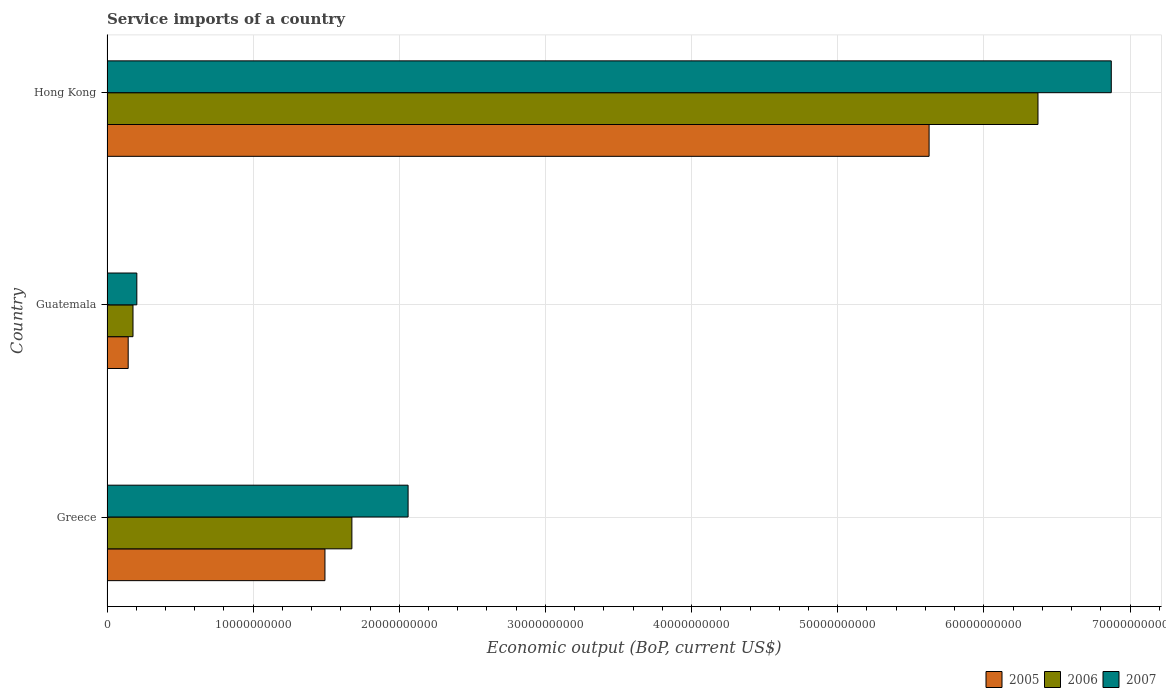Are the number of bars per tick equal to the number of legend labels?
Provide a succinct answer. Yes. Are the number of bars on each tick of the Y-axis equal?
Ensure brevity in your answer.  Yes. What is the label of the 2nd group of bars from the top?
Ensure brevity in your answer.  Guatemala. In how many cases, is the number of bars for a given country not equal to the number of legend labels?
Offer a very short reply. 0. What is the service imports in 2005 in Hong Kong?
Ensure brevity in your answer.  5.63e+1. Across all countries, what is the maximum service imports in 2005?
Ensure brevity in your answer.  5.63e+1. Across all countries, what is the minimum service imports in 2005?
Make the answer very short. 1.45e+09. In which country was the service imports in 2006 maximum?
Give a very brief answer. Hong Kong. In which country was the service imports in 2006 minimum?
Your response must be concise. Guatemala. What is the total service imports in 2005 in the graph?
Your answer should be compact. 7.26e+1. What is the difference between the service imports in 2007 in Guatemala and that in Hong Kong?
Offer a very short reply. -6.67e+1. What is the difference between the service imports in 2007 in Greece and the service imports in 2005 in Hong Kong?
Your answer should be very brief. -3.57e+1. What is the average service imports in 2005 per country?
Keep it short and to the point. 2.42e+1. What is the difference between the service imports in 2006 and service imports in 2005 in Guatemala?
Give a very brief answer. 3.29e+08. What is the ratio of the service imports in 2006 in Greece to that in Guatemala?
Make the answer very short. 9.42. Is the service imports in 2006 in Guatemala less than that in Hong Kong?
Provide a succinct answer. Yes. What is the difference between the highest and the second highest service imports in 2007?
Offer a terse response. 4.81e+1. What is the difference between the highest and the lowest service imports in 2006?
Your answer should be very brief. 6.19e+1. Is the sum of the service imports in 2006 in Greece and Hong Kong greater than the maximum service imports in 2007 across all countries?
Provide a succinct answer. Yes. Are all the bars in the graph horizontal?
Your response must be concise. Yes. How many countries are there in the graph?
Your answer should be compact. 3. Does the graph contain grids?
Your answer should be very brief. Yes. Where does the legend appear in the graph?
Your answer should be compact. Bottom right. How many legend labels are there?
Offer a very short reply. 3. What is the title of the graph?
Ensure brevity in your answer.  Service imports of a country. Does "1977" appear as one of the legend labels in the graph?
Your answer should be very brief. No. What is the label or title of the X-axis?
Make the answer very short. Economic output (BoP, current US$). What is the label or title of the Y-axis?
Make the answer very short. Country. What is the Economic output (BoP, current US$) of 2005 in Greece?
Your response must be concise. 1.49e+1. What is the Economic output (BoP, current US$) in 2006 in Greece?
Offer a very short reply. 1.68e+1. What is the Economic output (BoP, current US$) in 2007 in Greece?
Your answer should be very brief. 2.06e+1. What is the Economic output (BoP, current US$) in 2005 in Guatemala?
Provide a succinct answer. 1.45e+09. What is the Economic output (BoP, current US$) in 2006 in Guatemala?
Provide a succinct answer. 1.78e+09. What is the Economic output (BoP, current US$) in 2007 in Guatemala?
Provide a short and direct response. 2.04e+09. What is the Economic output (BoP, current US$) in 2005 in Hong Kong?
Your answer should be very brief. 5.63e+1. What is the Economic output (BoP, current US$) in 2006 in Hong Kong?
Make the answer very short. 6.37e+1. What is the Economic output (BoP, current US$) in 2007 in Hong Kong?
Offer a very short reply. 6.87e+1. Across all countries, what is the maximum Economic output (BoP, current US$) in 2005?
Keep it short and to the point. 5.63e+1. Across all countries, what is the maximum Economic output (BoP, current US$) in 2006?
Give a very brief answer. 6.37e+1. Across all countries, what is the maximum Economic output (BoP, current US$) of 2007?
Your answer should be compact. 6.87e+1. Across all countries, what is the minimum Economic output (BoP, current US$) in 2005?
Provide a succinct answer. 1.45e+09. Across all countries, what is the minimum Economic output (BoP, current US$) of 2006?
Your response must be concise. 1.78e+09. Across all countries, what is the minimum Economic output (BoP, current US$) of 2007?
Offer a terse response. 2.04e+09. What is the total Economic output (BoP, current US$) in 2005 in the graph?
Ensure brevity in your answer.  7.26e+1. What is the total Economic output (BoP, current US$) of 2006 in the graph?
Ensure brevity in your answer.  8.22e+1. What is the total Economic output (BoP, current US$) of 2007 in the graph?
Your answer should be compact. 9.14e+1. What is the difference between the Economic output (BoP, current US$) in 2005 in Greece and that in Guatemala?
Provide a short and direct response. 1.35e+1. What is the difference between the Economic output (BoP, current US$) in 2006 in Greece and that in Guatemala?
Your response must be concise. 1.50e+1. What is the difference between the Economic output (BoP, current US$) of 2007 in Greece and that in Guatemala?
Your answer should be very brief. 1.86e+1. What is the difference between the Economic output (BoP, current US$) in 2005 in Greece and that in Hong Kong?
Provide a succinct answer. -4.13e+1. What is the difference between the Economic output (BoP, current US$) of 2006 in Greece and that in Hong Kong?
Your response must be concise. -4.69e+1. What is the difference between the Economic output (BoP, current US$) of 2007 in Greece and that in Hong Kong?
Provide a short and direct response. -4.81e+1. What is the difference between the Economic output (BoP, current US$) of 2005 in Guatemala and that in Hong Kong?
Ensure brevity in your answer.  -5.48e+1. What is the difference between the Economic output (BoP, current US$) in 2006 in Guatemala and that in Hong Kong?
Give a very brief answer. -6.19e+1. What is the difference between the Economic output (BoP, current US$) of 2007 in Guatemala and that in Hong Kong?
Offer a very short reply. -6.67e+1. What is the difference between the Economic output (BoP, current US$) in 2005 in Greece and the Economic output (BoP, current US$) in 2006 in Guatemala?
Your answer should be compact. 1.31e+1. What is the difference between the Economic output (BoP, current US$) of 2005 in Greece and the Economic output (BoP, current US$) of 2007 in Guatemala?
Provide a short and direct response. 1.29e+1. What is the difference between the Economic output (BoP, current US$) of 2006 in Greece and the Economic output (BoP, current US$) of 2007 in Guatemala?
Make the answer very short. 1.47e+1. What is the difference between the Economic output (BoP, current US$) of 2005 in Greece and the Economic output (BoP, current US$) of 2006 in Hong Kong?
Give a very brief answer. -4.88e+1. What is the difference between the Economic output (BoP, current US$) in 2005 in Greece and the Economic output (BoP, current US$) in 2007 in Hong Kong?
Give a very brief answer. -5.38e+1. What is the difference between the Economic output (BoP, current US$) of 2006 in Greece and the Economic output (BoP, current US$) of 2007 in Hong Kong?
Your answer should be very brief. -5.20e+1. What is the difference between the Economic output (BoP, current US$) in 2005 in Guatemala and the Economic output (BoP, current US$) in 2006 in Hong Kong?
Ensure brevity in your answer.  -6.23e+1. What is the difference between the Economic output (BoP, current US$) of 2005 in Guatemala and the Economic output (BoP, current US$) of 2007 in Hong Kong?
Offer a terse response. -6.73e+1. What is the difference between the Economic output (BoP, current US$) of 2006 in Guatemala and the Economic output (BoP, current US$) of 2007 in Hong Kong?
Give a very brief answer. -6.69e+1. What is the average Economic output (BoP, current US$) of 2005 per country?
Your response must be concise. 2.42e+1. What is the average Economic output (BoP, current US$) of 2006 per country?
Provide a short and direct response. 2.74e+1. What is the average Economic output (BoP, current US$) of 2007 per country?
Your response must be concise. 3.05e+1. What is the difference between the Economic output (BoP, current US$) of 2005 and Economic output (BoP, current US$) of 2006 in Greece?
Provide a short and direct response. -1.84e+09. What is the difference between the Economic output (BoP, current US$) in 2005 and Economic output (BoP, current US$) in 2007 in Greece?
Your answer should be very brief. -5.69e+09. What is the difference between the Economic output (BoP, current US$) in 2006 and Economic output (BoP, current US$) in 2007 in Greece?
Ensure brevity in your answer.  -3.85e+09. What is the difference between the Economic output (BoP, current US$) of 2005 and Economic output (BoP, current US$) of 2006 in Guatemala?
Provide a succinct answer. -3.29e+08. What is the difference between the Economic output (BoP, current US$) in 2005 and Economic output (BoP, current US$) in 2007 in Guatemala?
Your response must be concise. -5.92e+08. What is the difference between the Economic output (BoP, current US$) in 2006 and Economic output (BoP, current US$) in 2007 in Guatemala?
Give a very brief answer. -2.63e+08. What is the difference between the Economic output (BoP, current US$) of 2005 and Economic output (BoP, current US$) of 2006 in Hong Kong?
Provide a short and direct response. -7.45e+09. What is the difference between the Economic output (BoP, current US$) in 2005 and Economic output (BoP, current US$) in 2007 in Hong Kong?
Give a very brief answer. -1.25e+1. What is the difference between the Economic output (BoP, current US$) of 2006 and Economic output (BoP, current US$) of 2007 in Hong Kong?
Provide a succinct answer. -5.01e+09. What is the ratio of the Economic output (BoP, current US$) in 2005 in Greece to that in Guatemala?
Make the answer very short. 10.29. What is the ratio of the Economic output (BoP, current US$) in 2006 in Greece to that in Guatemala?
Your answer should be compact. 9.42. What is the ratio of the Economic output (BoP, current US$) in 2007 in Greece to that in Guatemala?
Offer a very short reply. 10.09. What is the ratio of the Economic output (BoP, current US$) of 2005 in Greece to that in Hong Kong?
Offer a terse response. 0.27. What is the ratio of the Economic output (BoP, current US$) of 2006 in Greece to that in Hong Kong?
Give a very brief answer. 0.26. What is the ratio of the Economic output (BoP, current US$) of 2007 in Greece to that in Hong Kong?
Keep it short and to the point. 0.3. What is the ratio of the Economic output (BoP, current US$) in 2005 in Guatemala to that in Hong Kong?
Offer a terse response. 0.03. What is the ratio of the Economic output (BoP, current US$) of 2006 in Guatemala to that in Hong Kong?
Keep it short and to the point. 0.03. What is the ratio of the Economic output (BoP, current US$) of 2007 in Guatemala to that in Hong Kong?
Keep it short and to the point. 0.03. What is the difference between the highest and the second highest Economic output (BoP, current US$) of 2005?
Provide a succinct answer. 4.13e+1. What is the difference between the highest and the second highest Economic output (BoP, current US$) of 2006?
Offer a terse response. 4.69e+1. What is the difference between the highest and the second highest Economic output (BoP, current US$) of 2007?
Ensure brevity in your answer.  4.81e+1. What is the difference between the highest and the lowest Economic output (BoP, current US$) of 2005?
Provide a succinct answer. 5.48e+1. What is the difference between the highest and the lowest Economic output (BoP, current US$) of 2006?
Your response must be concise. 6.19e+1. What is the difference between the highest and the lowest Economic output (BoP, current US$) of 2007?
Your answer should be compact. 6.67e+1. 